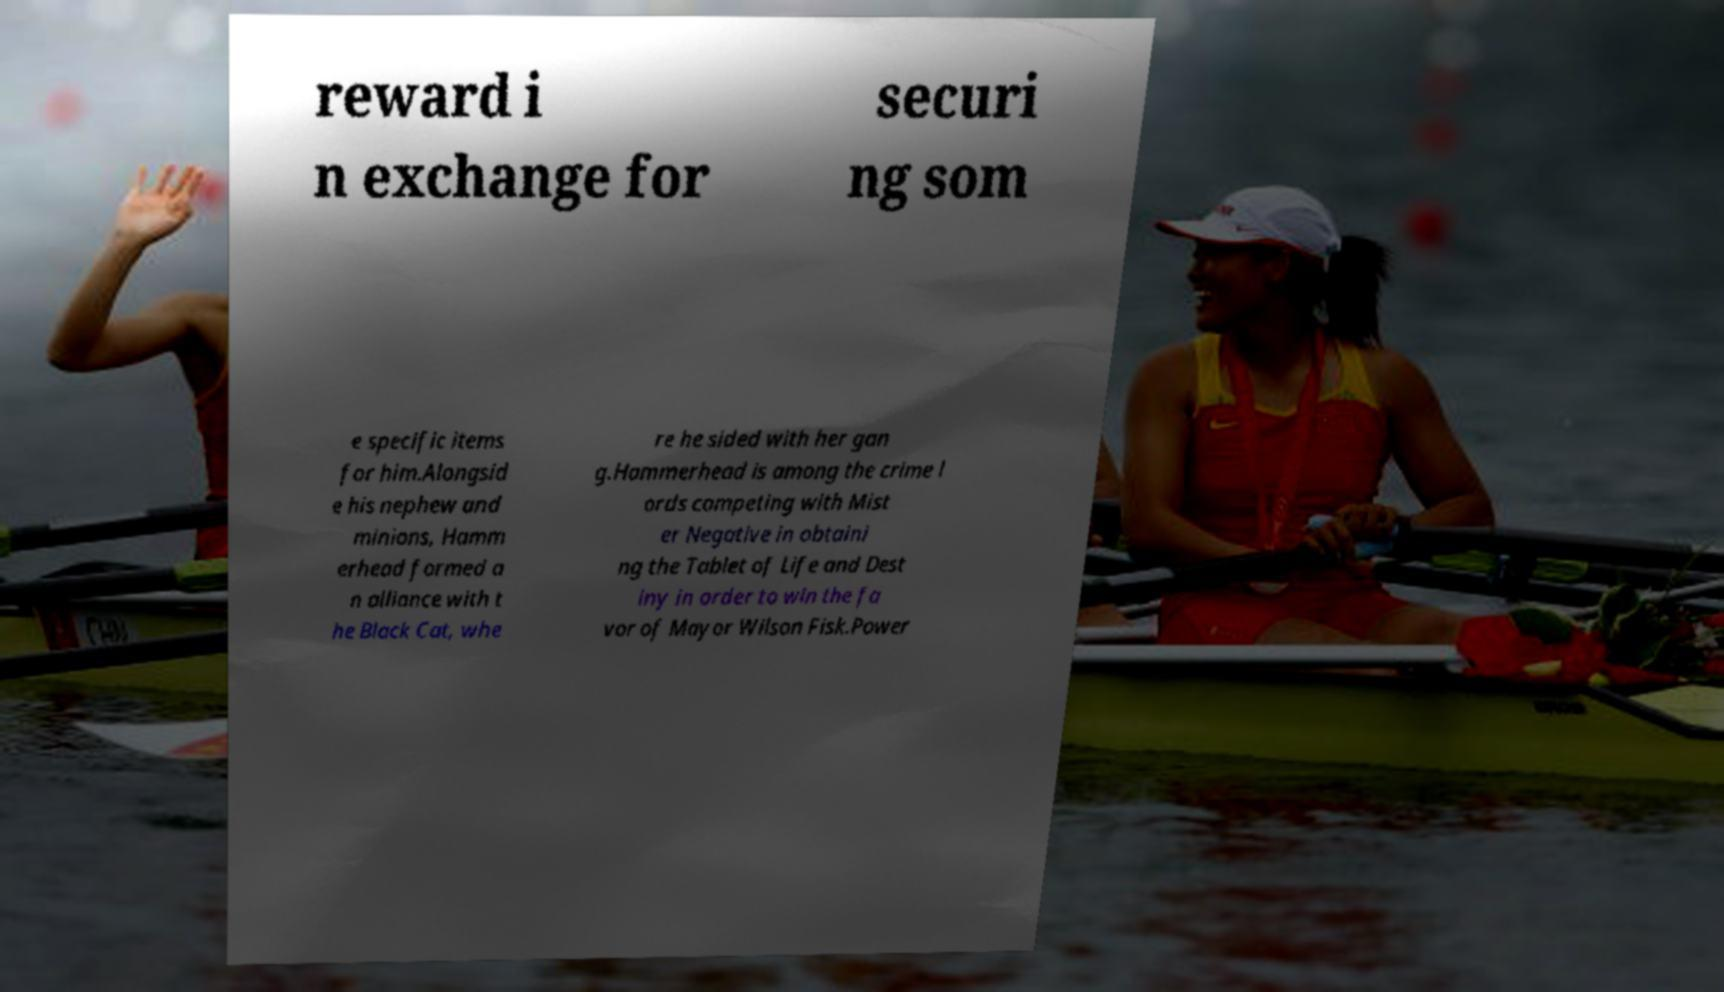There's text embedded in this image that I need extracted. Can you transcribe it verbatim? reward i n exchange for securi ng som e specific items for him.Alongsid e his nephew and minions, Hamm erhead formed a n alliance with t he Black Cat, whe re he sided with her gan g.Hammerhead is among the crime l ords competing with Mist er Negative in obtaini ng the Tablet of Life and Dest iny in order to win the fa vor of Mayor Wilson Fisk.Power 